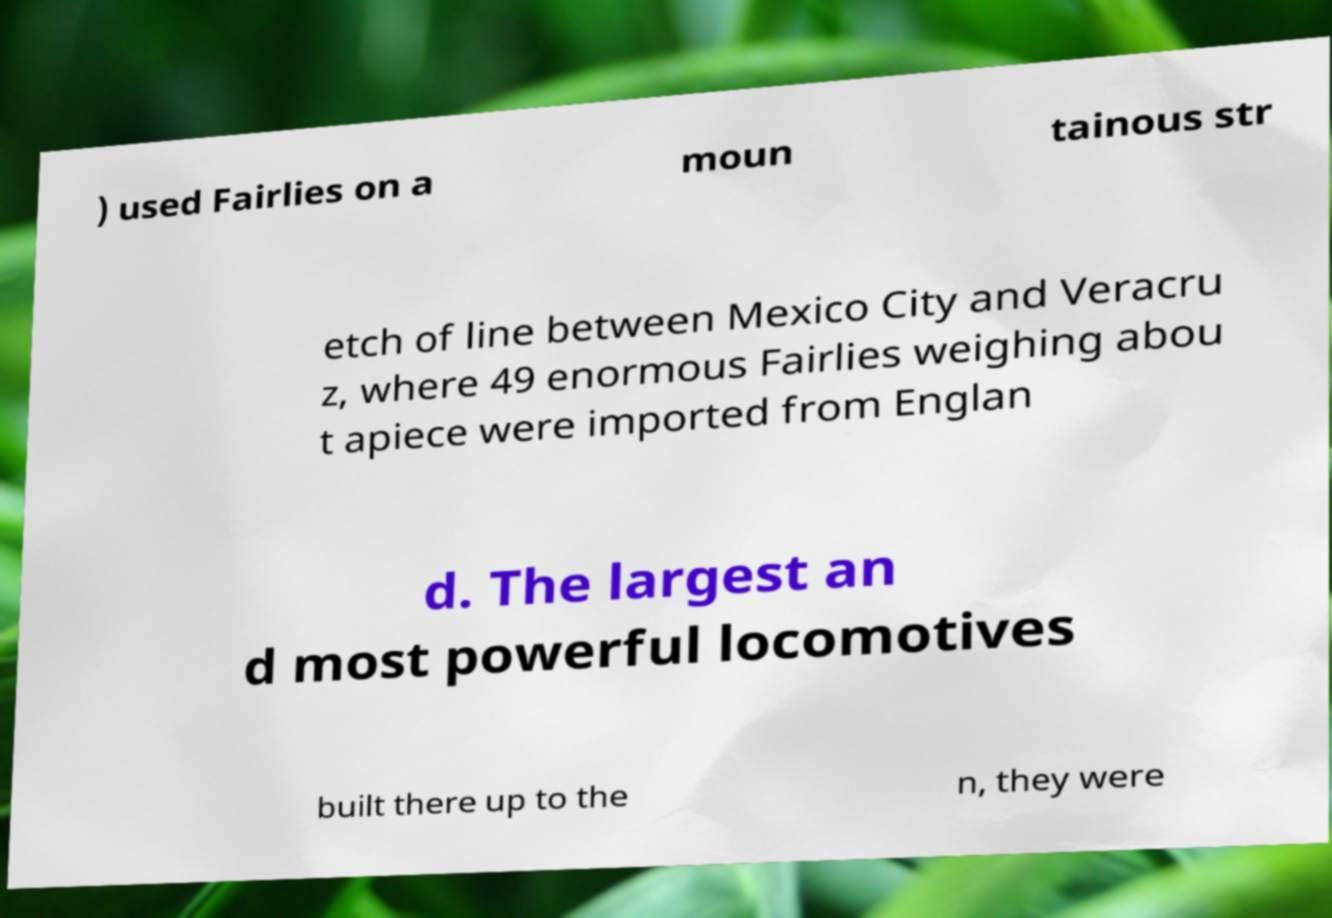For documentation purposes, I need the text within this image transcribed. Could you provide that? ) used Fairlies on a moun tainous str etch of line between Mexico City and Veracru z, where 49 enormous Fairlies weighing abou t apiece were imported from Englan d. The largest an d most powerful locomotives built there up to the n, they were 